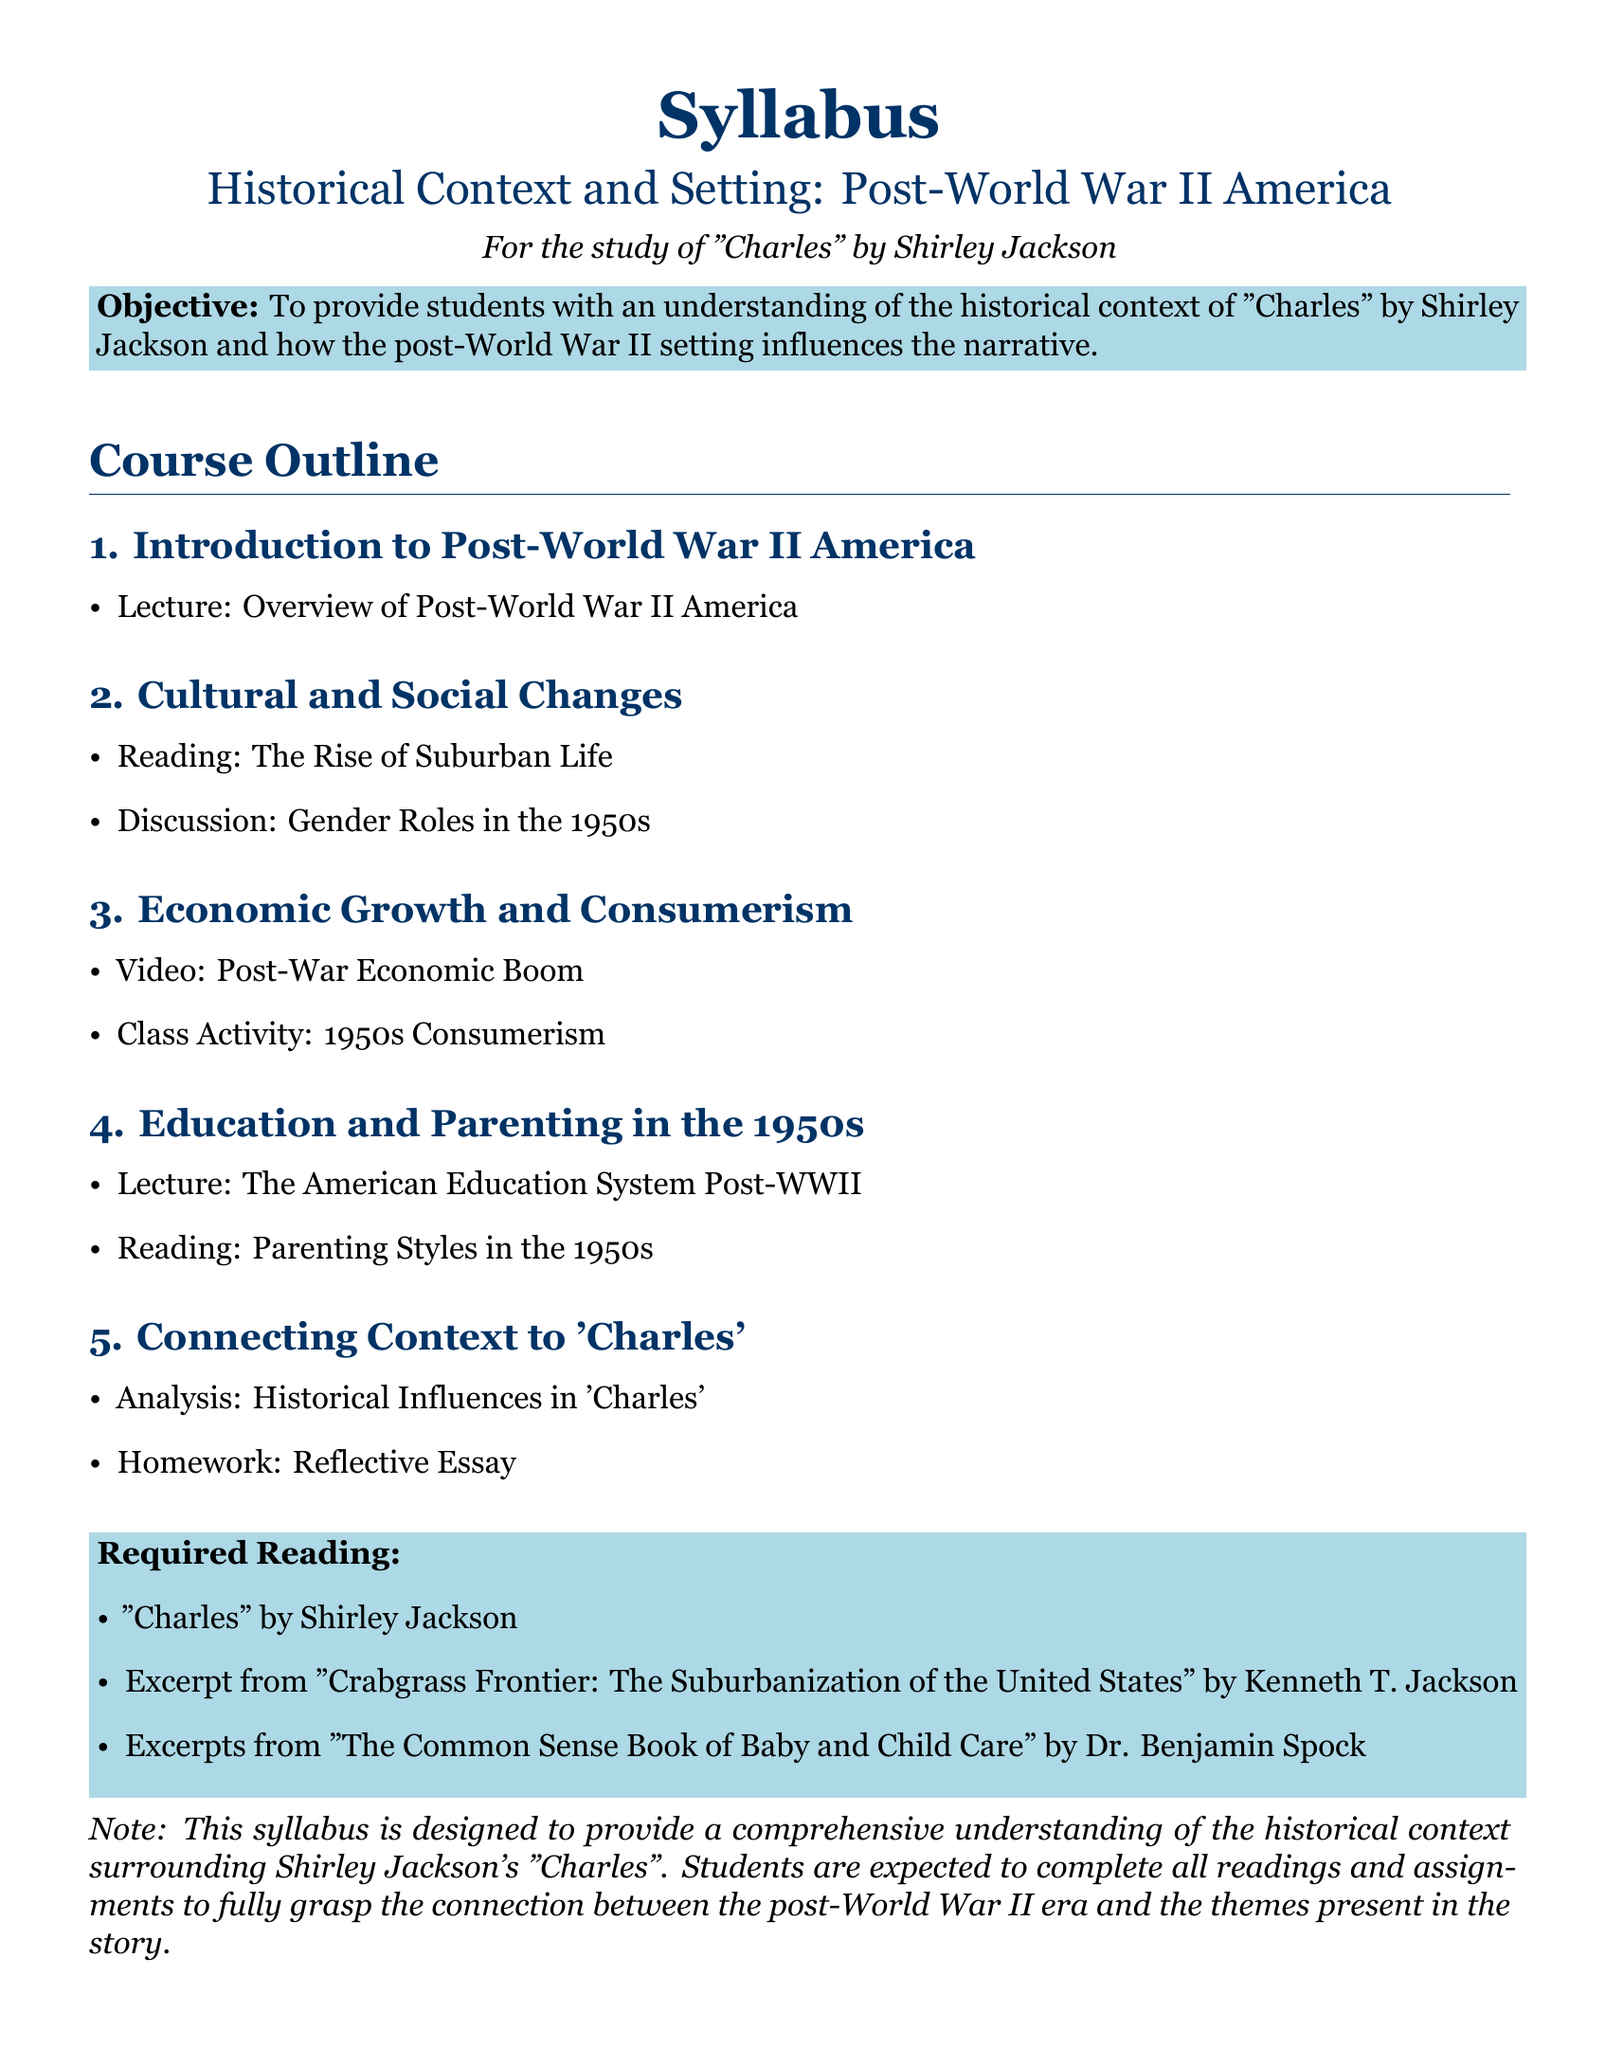What is the title of the syllabus? The title of the syllabus is stated at the top of the document.
Answer: Syllabus What is the main objective of the course? The objective is outlined in the colored box towards the beginning of the document.
Answer: To provide students with an understanding of the historical context of "Charles" by Shirley Jackson and how the post-World War II setting influences the narrative Which author wrote "Charles"? The author is listed under the Required Reading section of the syllabus.
Answer: Shirley Jackson What is one of the required readings? The required readings are specified in a list in the colored box.
Answer: Excerpt from "Crabgrass Frontier: The Suburbanization of the United States" by Kenneth T. Jackson How many main sections are in the course outline? The main sections are counted in the Course Outline.
Answer: Five What decade is primarily focused on in the course? The time frame being discussed is mentioned in the title and various course components.
Answer: 1950s What type of class activity is planned? The class activities are listed under the Economic Growth and Consumerism section.
Answer: 1950s Consumerism What kind of essay is assigned as homework? The type of homework is indicated in the Connecting Context to 'Charles' section.
Answer: Reflective Essay Which video topic is included in the syllabus? The video topic is detailed in the Economic Growth and Consumerism section.
Answer: Post-War Economic Boom 